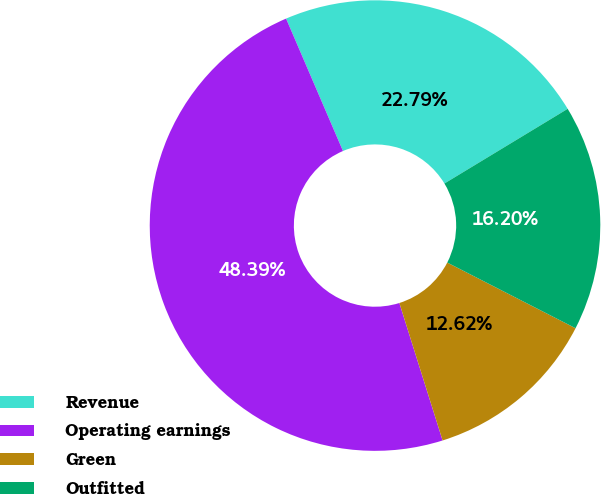Convert chart to OTSL. <chart><loc_0><loc_0><loc_500><loc_500><pie_chart><fcel>Revenue<fcel>Operating earnings<fcel>Green<fcel>Outfitted<nl><fcel>22.79%<fcel>48.39%<fcel>12.62%<fcel>16.2%<nl></chart> 